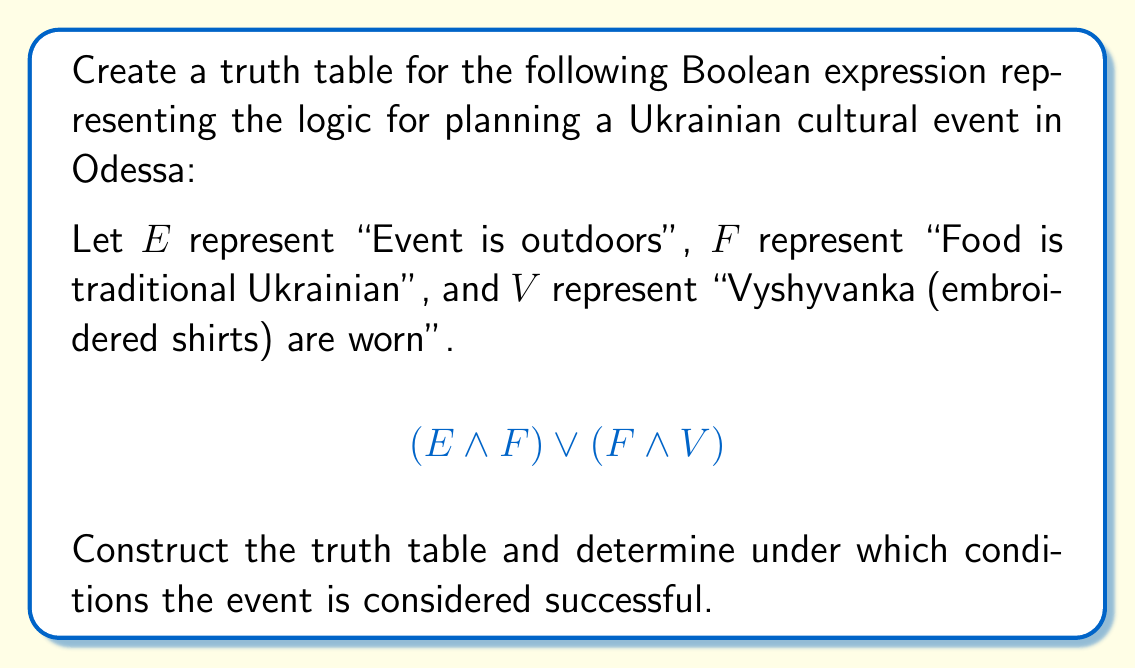Could you help me with this problem? To create a truth table for this Boolean expression, we need to follow these steps:

1. Identify the variables: $E$, $F$, and $V$
2. List all possible combinations of these variables (8 in total, as we have 3 variables)
3. Evaluate the subexpressions: $(E \land F)$ and $(F \land V)$
4. Evaluate the final expression: $(E \land F) \lor (F \land V)$

Here's the truth table:

$$
\begin{array}{|c|c|c|c|c|c|}
\hline
E & F & V & (E \land F) & (F \land V) & (E \land F) \lor (F \land V) \\
\hline
0 & 0 & 0 & 0 & 0 & 0 \\
0 & 0 & 1 & 0 & 0 & 0 \\
0 & 1 & 0 & 0 & 0 & 0 \\
0 & 1 & 1 & 0 & 1 & 1 \\
1 & 0 & 0 & 0 & 0 & 0 \\
1 & 0 & 1 & 0 & 0 & 0 \\
1 & 1 & 0 & 1 & 0 & 1 \\
1 & 1 & 1 & 1 & 1 & 1 \\
\hline
\end{array}
$$

From this truth table, we can see that the event is considered successful (output is 1) in three cases:

1. When $E = 0$, $F = 1$, and $V = 1$
2. When $E = 1$, $F = 1$, and $V = 0$
3. When $E = 1$, $F = 1$, and $V = 1$

This means the event is successful when:
- The event is indoors, with traditional Ukrainian food and Vyshyvanka worn
- The event is outdoors, with traditional Ukrainian food, regardless of whether Vyshyvanka is worn or not
Answer: Event is successful when: (indoors AND Ukrainian food AND Vyshyvanka) OR (outdoors AND Ukrainian food) 